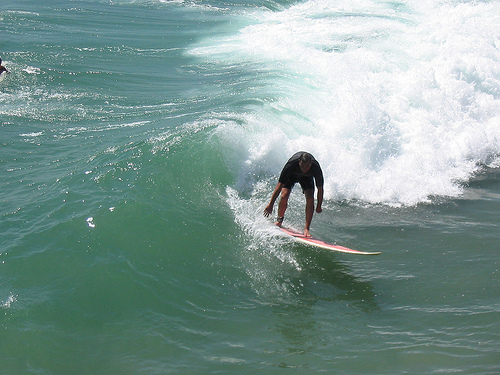Please provide the bounding box coordinate of the region this sentence describes: this is a wave. Coordinates for the wave region are [0.63, 0.32, 0.73, 0.47]. The wave appears to be cresting on the left side of the surfer. 